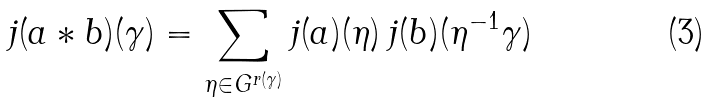<formula> <loc_0><loc_0><loc_500><loc_500>j ( a * b ) ( \gamma ) = \sum _ { \eta \in G ^ { r ( \gamma ) } } j ( a ) ( \eta ) \, j ( b ) ( \eta ^ { - 1 } \gamma )</formula> 